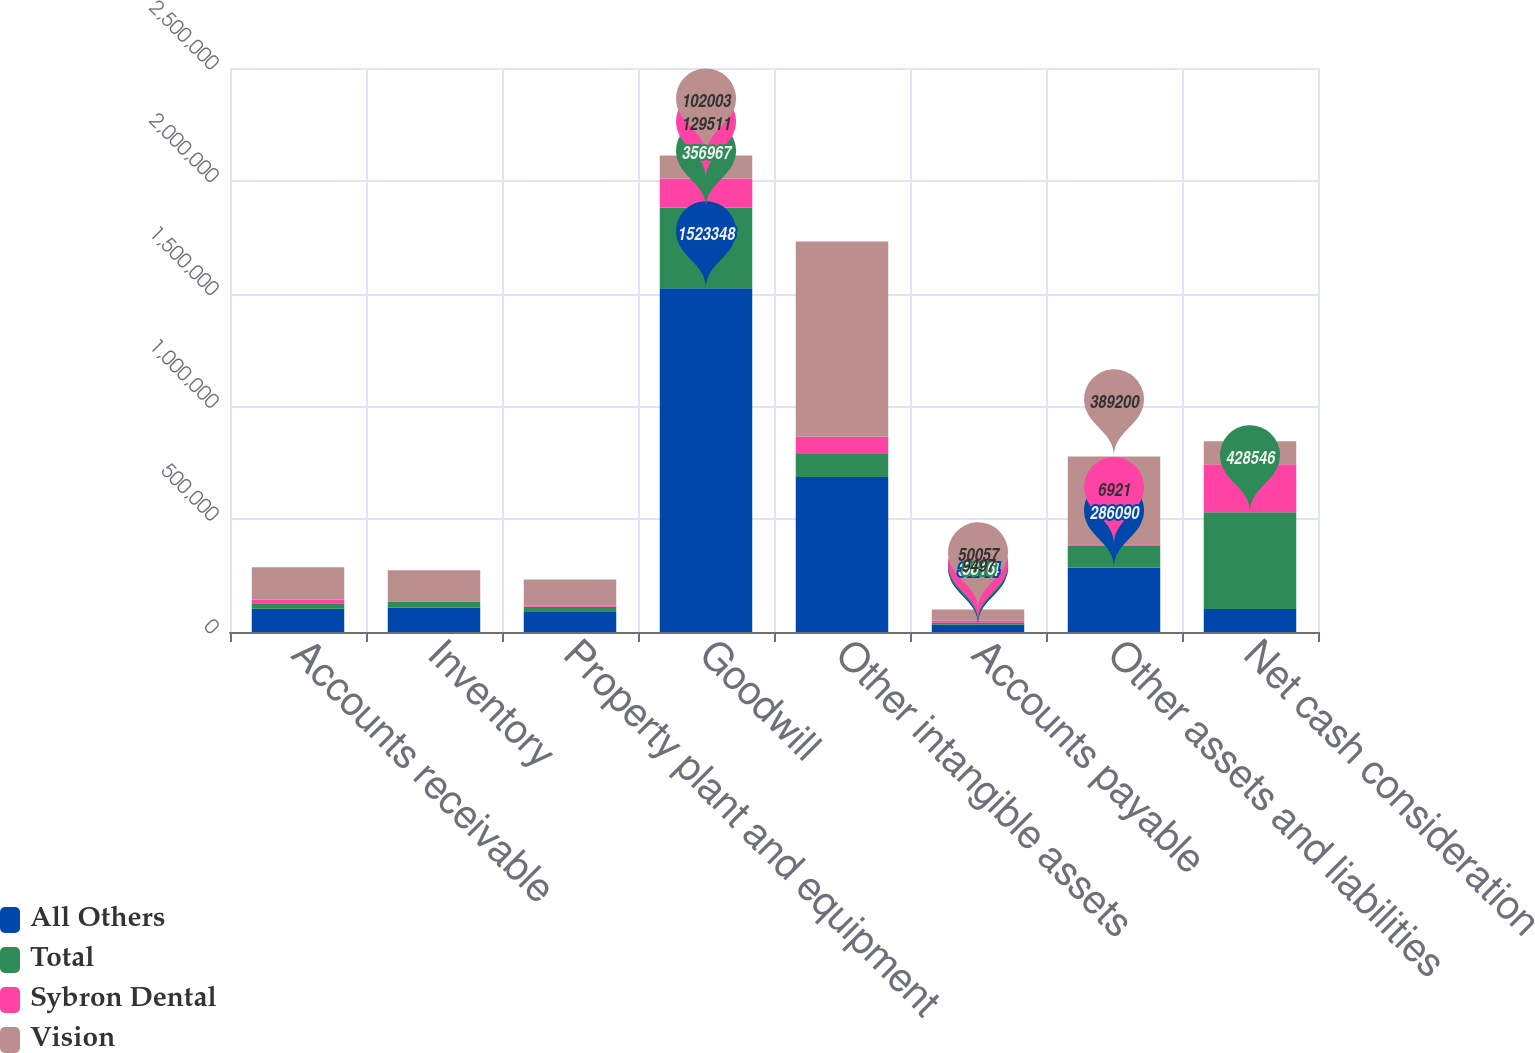<chart> <loc_0><loc_0><loc_500><loc_500><stacked_bar_chart><ecel><fcel>Accounts receivable<fcel>Inventory<fcel>Property plant and equipment<fcel>Goodwill<fcel>Other intangible assets<fcel>Accounts payable<fcel>Other assets and liabilities<fcel>Net cash consideration<nl><fcel>All Others<fcel>103335<fcel>108777<fcel>91769<fcel>1.52335e+06<fcel>686900<fcel>31744<fcel>286090<fcel>102003<nl><fcel>Total<fcel>24165<fcel>24709<fcel>20703<fcel>356967<fcel>102003<fcel>8816<fcel>96189<fcel>428546<nl><fcel>Sybron Dental<fcel>15941<fcel>3369<fcel>3916<fcel>129511<fcel>76546<fcel>9497<fcel>6921<fcel>212865<nl><fcel>Vision<fcel>143441<fcel>136855<fcel>116388<fcel>102003<fcel>865449<fcel>50057<fcel>389200<fcel>102003<nl></chart> 